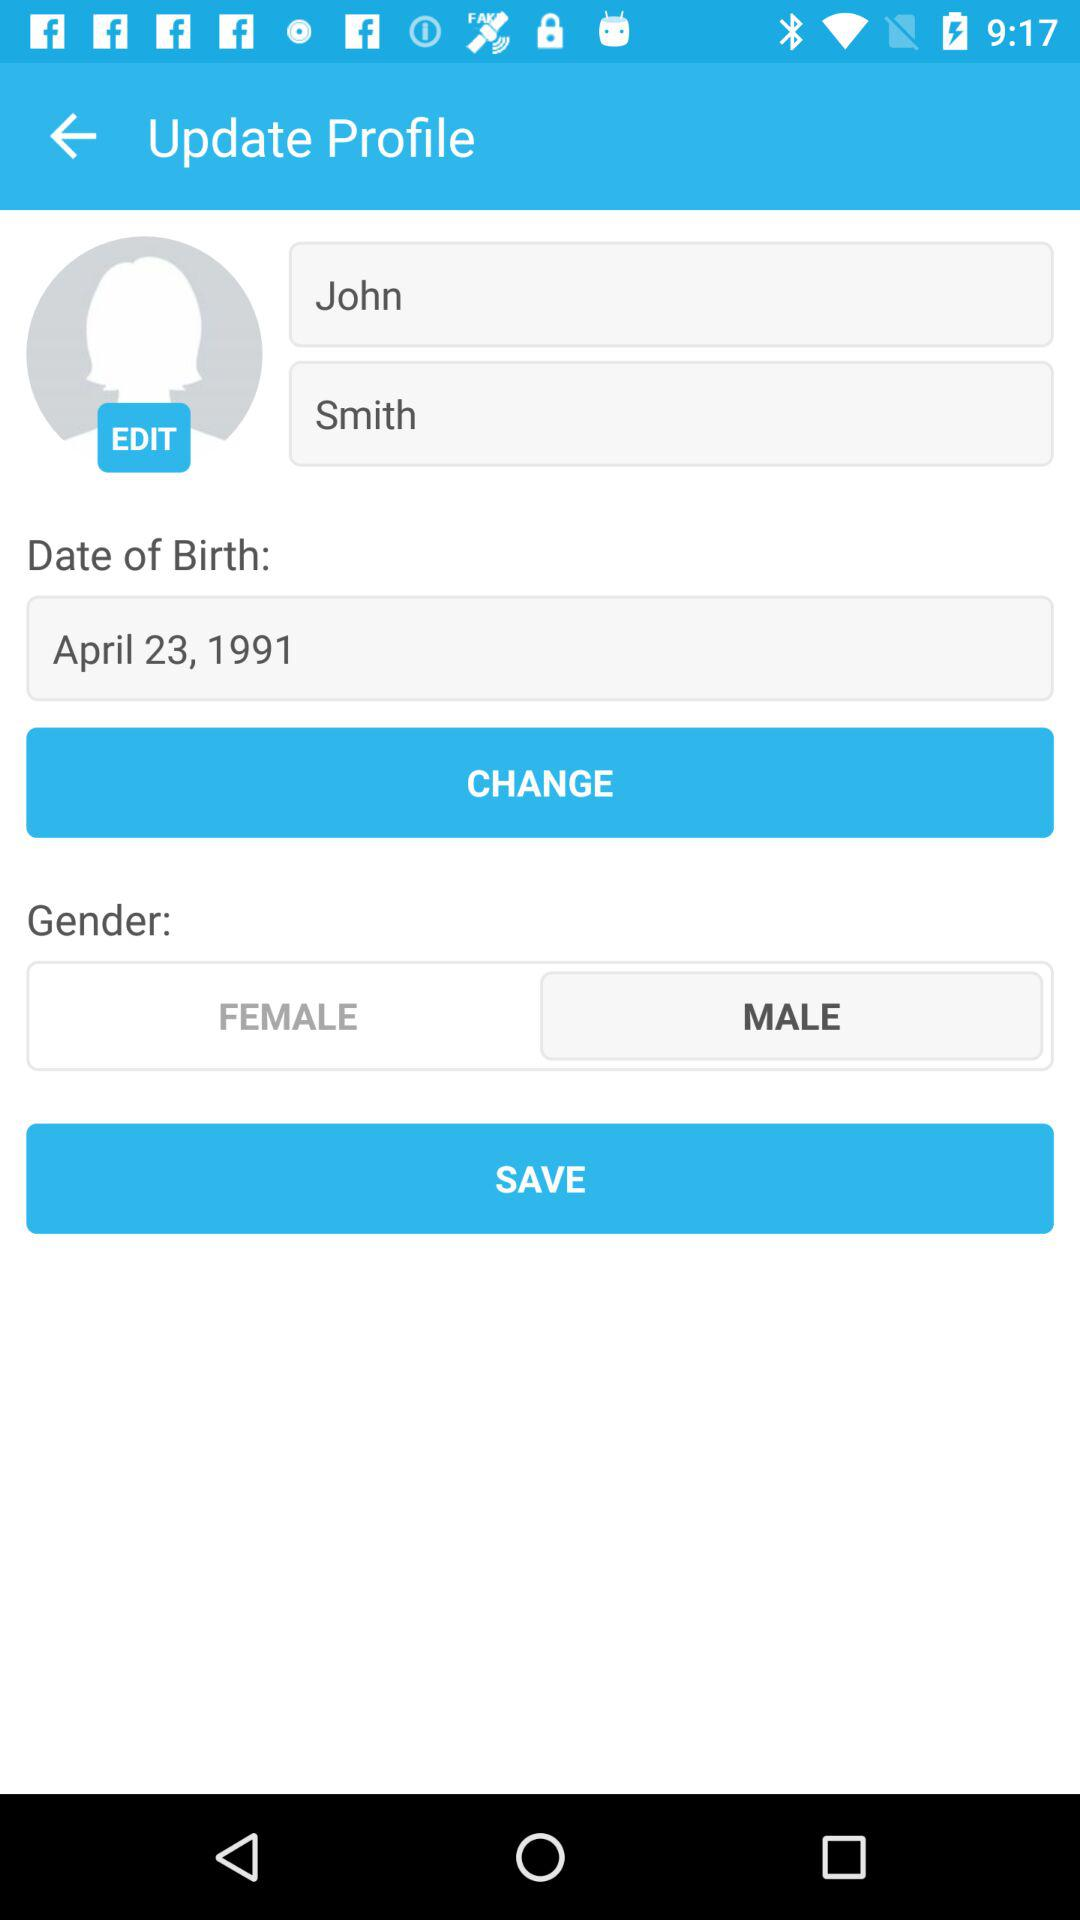What is the user profile name? The user profile name is John Smith. 